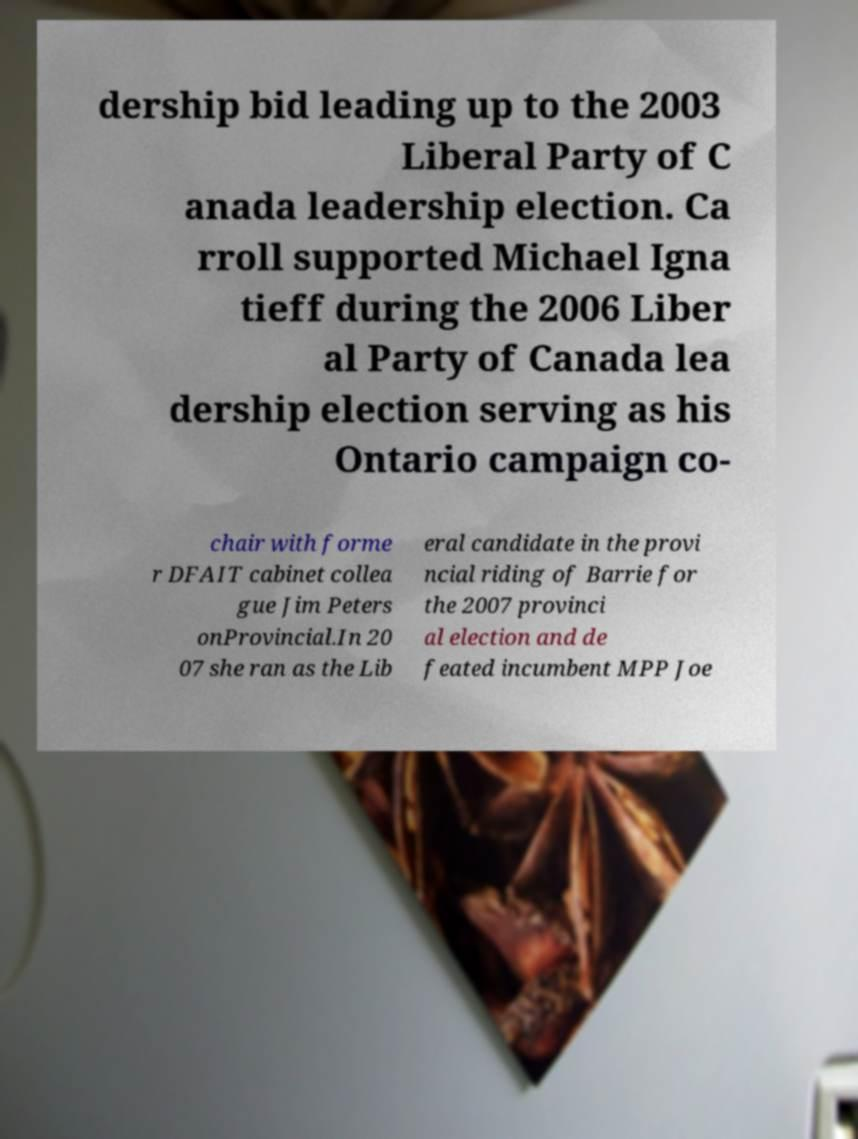Could you extract and type out the text from this image? dership bid leading up to the 2003 Liberal Party of C anada leadership election. Ca rroll supported Michael Igna tieff during the 2006 Liber al Party of Canada lea dership election serving as his Ontario campaign co- chair with forme r DFAIT cabinet collea gue Jim Peters onProvincial.In 20 07 she ran as the Lib eral candidate in the provi ncial riding of Barrie for the 2007 provinci al election and de feated incumbent MPP Joe 